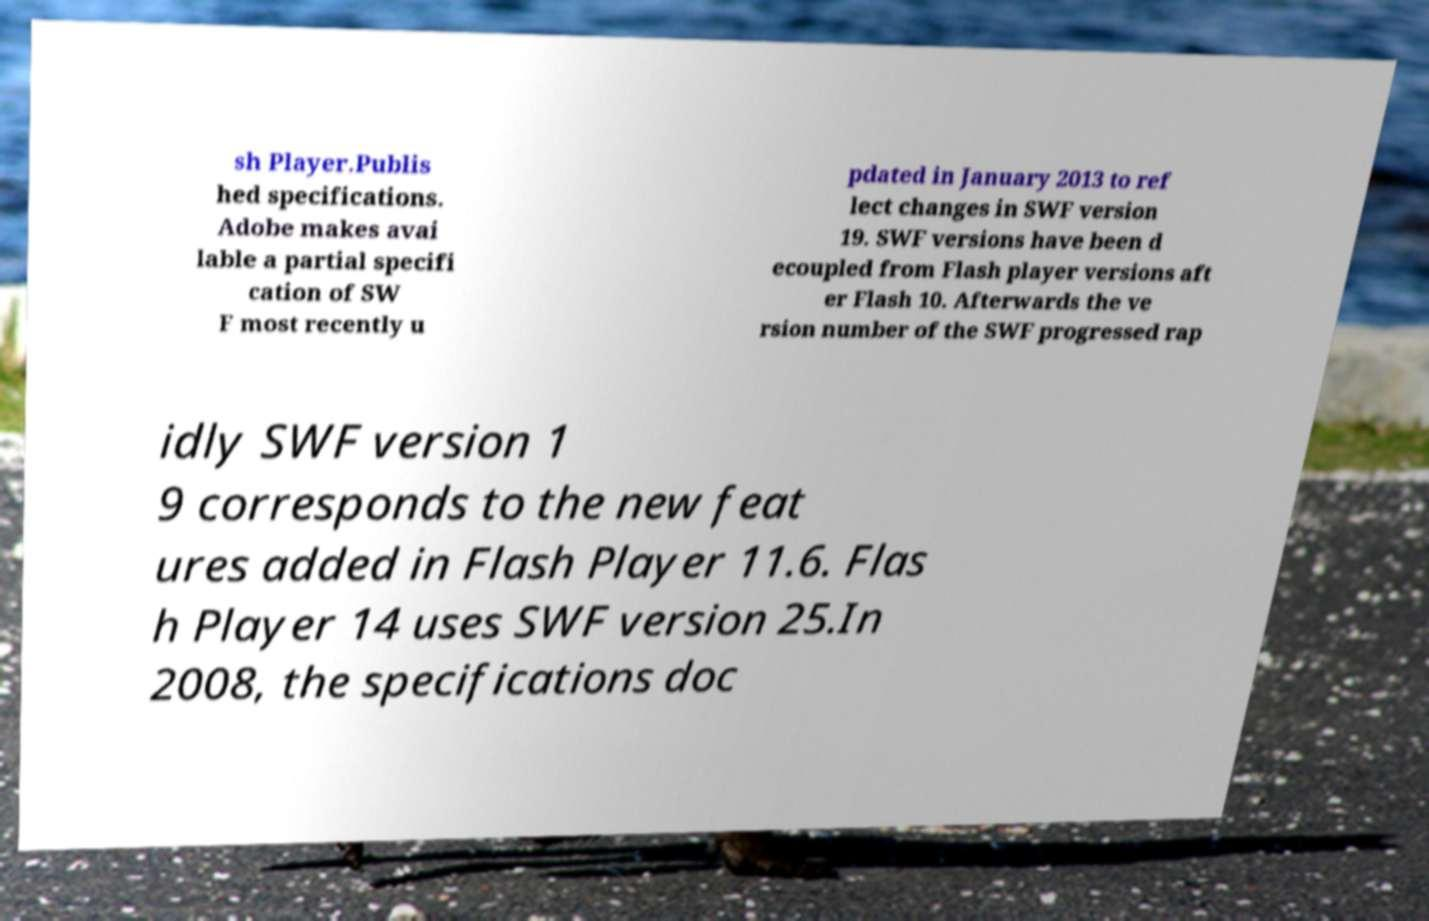For documentation purposes, I need the text within this image transcribed. Could you provide that? sh Player.Publis hed specifications. Adobe makes avai lable a partial specifi cation of SW F most recently u pdated in January 2013 to ref lect changes in SWF version 19. SWF versions have been d ecoupled from Flash player versions aft er Flash 10. Afterwards the ve rsion number of the SWF progressed rap idly SWF version 1 9 corresponds to the new feat ures added in Flash Player 11.6. Flas h Player 14 uses SWF version 25.In 2008, the specifications doc 